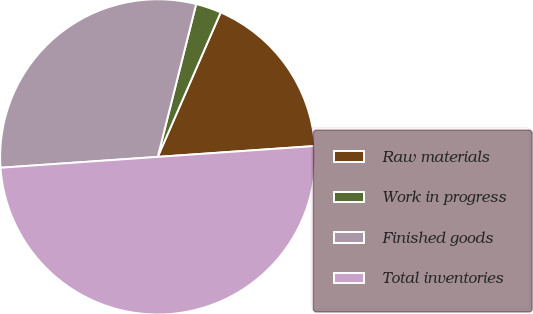Convert chart. <chart><loc_0><loc_0><loc_500><loc_500><pie_chart><fcel>Raw materials<fcel>Work in progress<fcel>Finished goods<fcel>Total inventories<nl><fcel>17.36%<fcel>2.62%<fcel>30.02%<fcel>50.0%<nl></chart> 